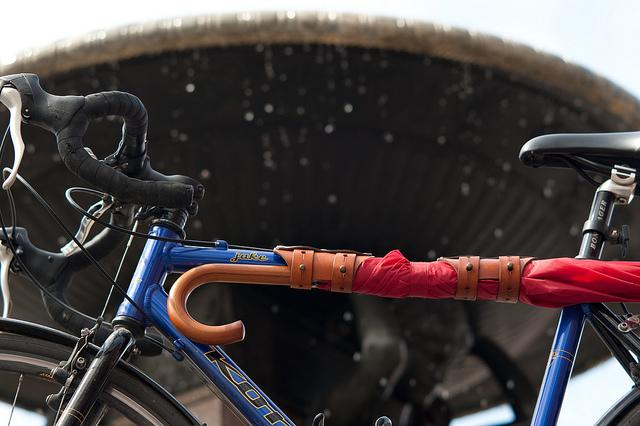The cyclist is most prepared for which weather today? Please explain your reasoning. rain. There is an umbrella strapped to the bike which will keep him dry. 